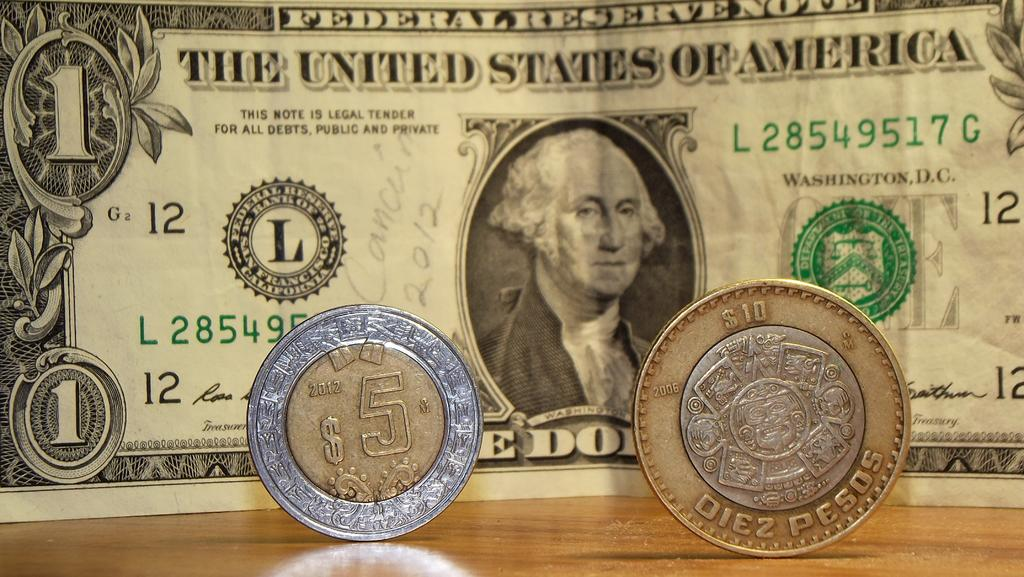<image>
Share a concise interpretation of the image provided. The $10 and $5 pesos coins are both smaller than the American dollar bill. 